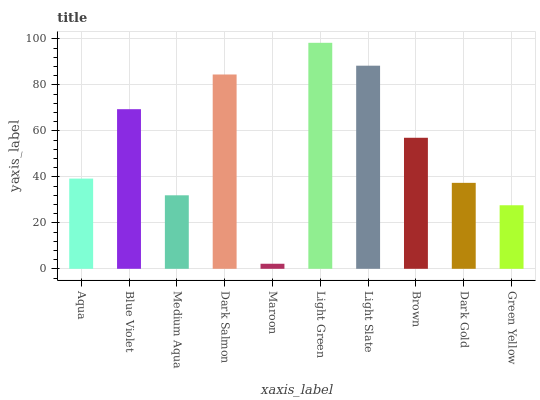Is Maroon the minimum?
Answer yes or no. Yes. Is Light Green the maximum?
Answer yes or no. Yes. Is Blue Violet the minimum?
Answer yes or no. No. Is Blue Violet the maximum?
Answer yes or no. No. Is Blue Violet greater than Aqua?
Answer yes or no. Yes. Is Aqua less than Blue Violet?
Answer yes or no. Yes. Is Aqua greater than Blue Violet?
Answer yes or no. No. Is Blue Violet less than Aqua?
Answer yes or no. No. Is Brown the high median?
Answer yes or no. Yes. Is Aqua the low median?
Answer yes or no. Yes. Is Medium Aqua the high median?
Answer yes or no. No. Is Maroon the low median?
Answer yes or no. No. 